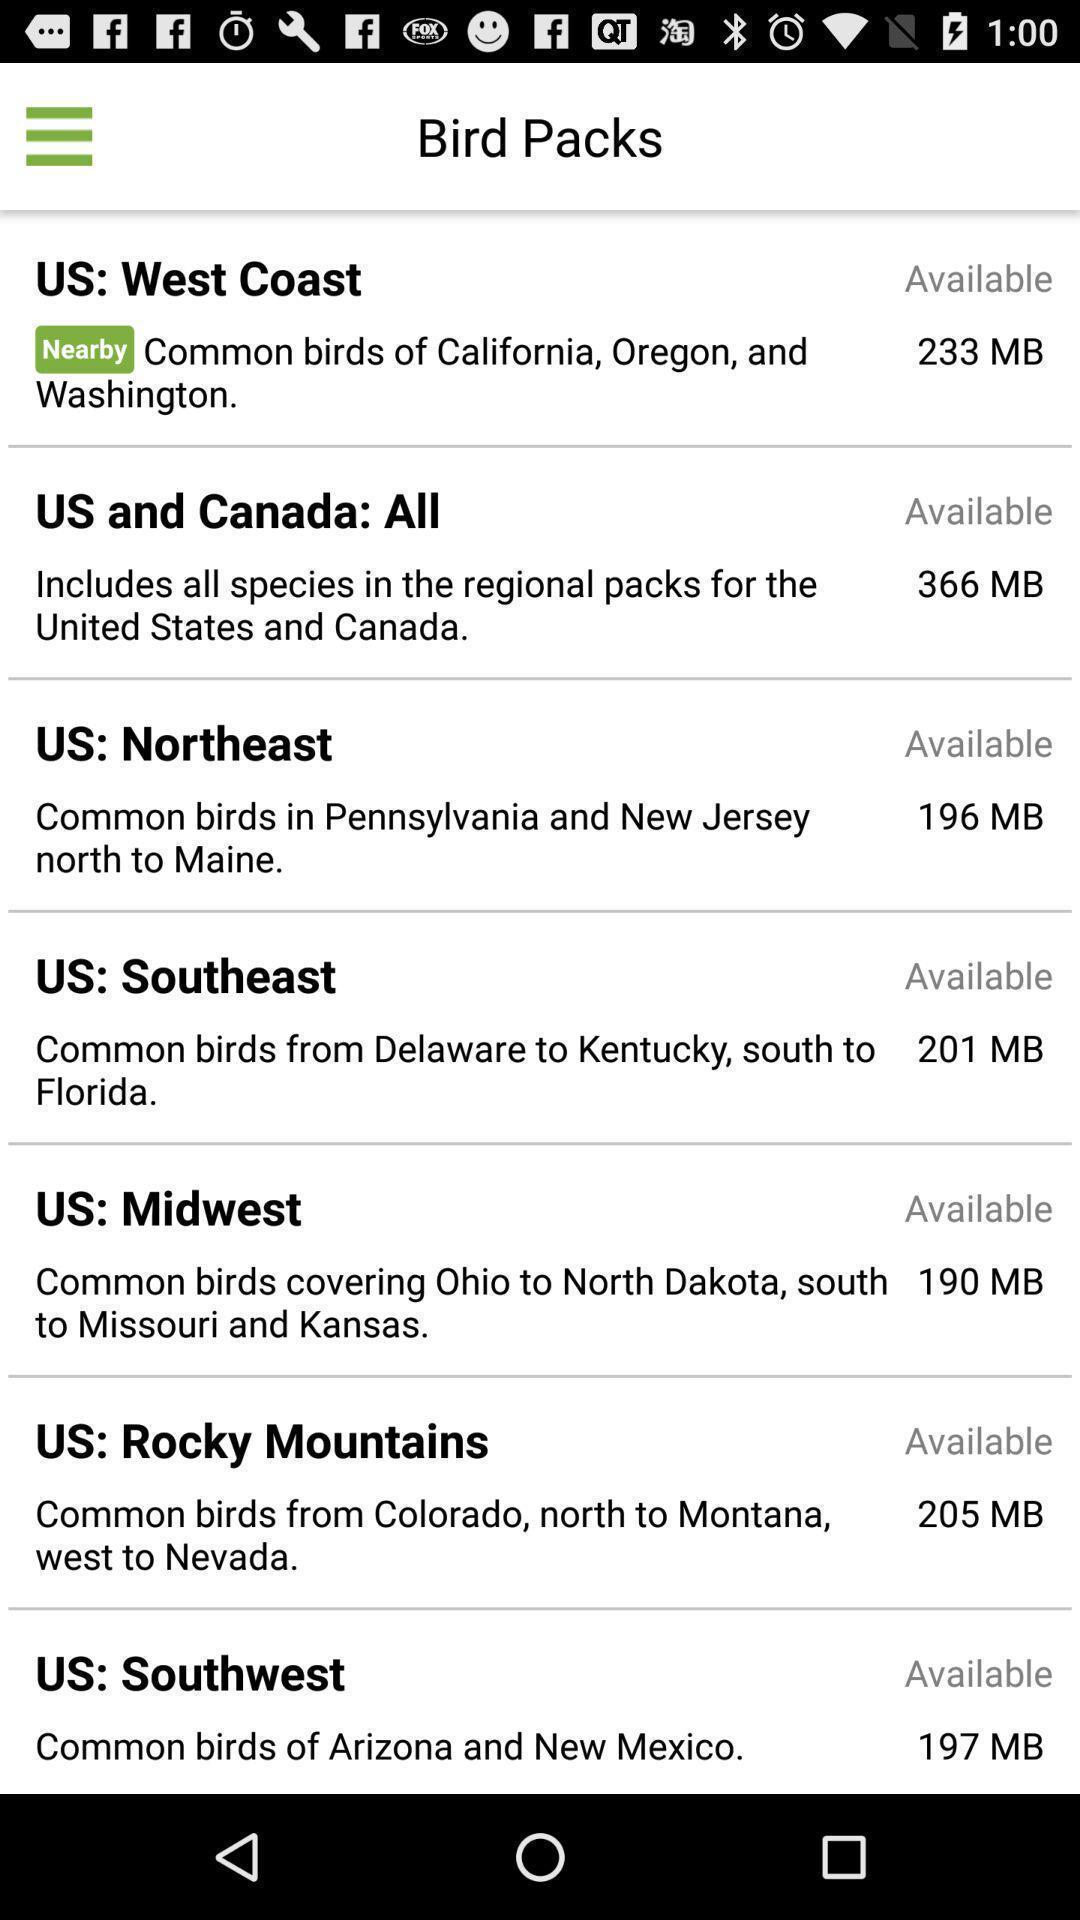Give me a summary of this screen capture. Screen shows different packs in the bird application. 